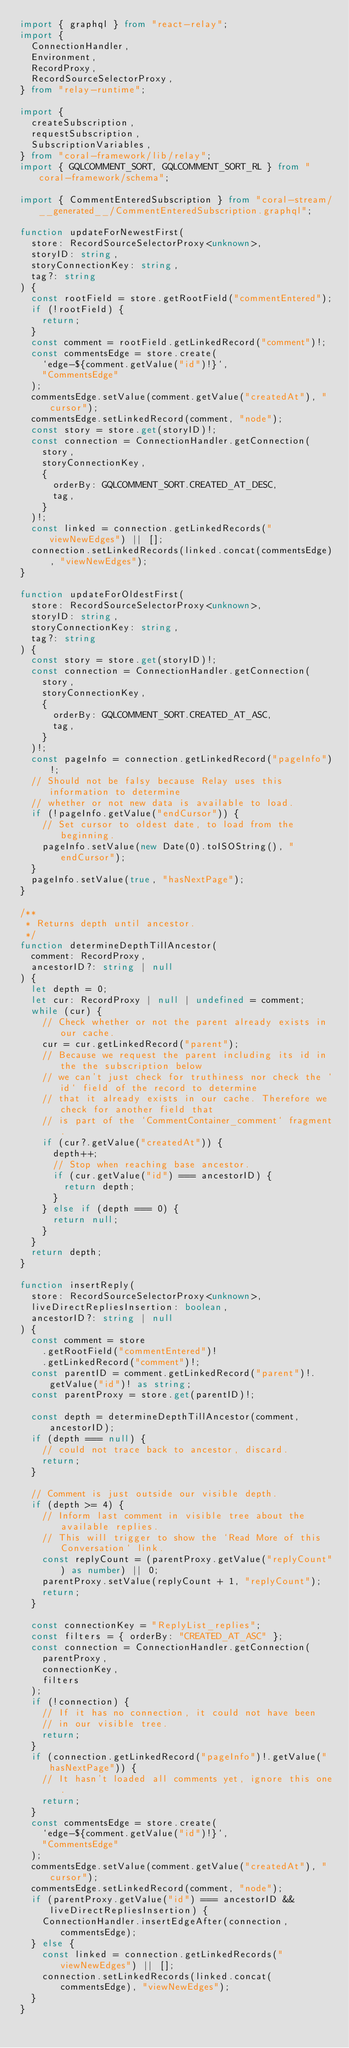Convert code to text. <code><loc_0><loc_0><loc_500><loc_500><_TypeScript_>import { graphql } from "react-relay";
import {
  ConnectionHandler,
  Environment,
  RecordProxy,
  RecordSourceSelectorProxy,
} from "relay-runtime";

import {
  createSubscription,
  requestSubscription,
  SubscriptionVariables,
} from "coral-framework/lib/relay";
import { GQLCOMMENT_SORT, GQLCOMMENT_SORT_RL } from "coral-framework/schema";

import { CommentEnteredSubscription } from "coral-stream/__generated__/CommentEnteredSubscription.graphql";

function updateForNewestFirst(
  store: RecordSourceSelectorProxy<unknown>,
  storyID: string,
  storyConnectionKey: string,
  tag?: string
) {
  const rootField = store.getRootField("commentEntered");
  if (!rootField) {
    return;
  }
  const comment = rootField.getLinkedRecord("comment")!;
  const commentsEdge = store.create(
    `edge-${comment.getValue("id")!}`,
    "CommentsEdge"
  );
  commentsEdge.setValue(comment.getValue("createdAt"), "cursor");
  commentsEdge.setLinkedRecord(comment, "node");
  const story = store.get(storyID)!;
  const connection = ConnectionHandler.getConnection(
    story,
    storyConnectionKey,
    {
      orderBy: GQLCOMMENT_SORT.CREATED_AT_DESC,
      tag,
    }
  )!;
  const linked = connection.getLinkedRecords("viewNewEdges") || [];
  connection.setLinkedRecords(linked.concat(commentsEdge), "viewNewEdges");
}

function updateForOldestFirst(
  store: RecordSourceSelectorProxy<unknown>,
  storyID: string,
  storyConnectionKey: string,
  tag?: string
) {
  const story = store.get(storyID)!;
  const connection = ConnectionHandler.getConnection(
    story,
    storyConnectionKey,
    {
      orderBy: GQLCOMMENT_SORT.CREATED_AT_ASC,
      tag,
    }
  )!;
  const pageInfo = connection.getLinkedRecord("pageInfo")!;
  // Should not be falsy because Relay uses this information to determine
  // whether or not new data is available to load.
  if (!pageInfo.getValue("endCursor")) {
    // Set cursor to oldest date, to load from the beginning.
    pageInfo.setValue(new Date(0).toISOString(), "endCursor");
  }
  pageInfo.setValue(true, "hasNextPage");
}

/**
 * Returns depth until ancestor.
 */
function determineDepthTillAncestor(
  comment: RecordProxy,
  ancestorID?: string | null
) {
  let depth = 0;
  let cur: RecordProxy | null | undefined = comment;
  while (cur) {
    // Check whether or not the parent already exists in our cache.
    cur = cur.getLinkedRecord("parent");
    // Because we request the parent including its id in the the subscription below
    // we can't just check for truthiness nor check the `id` field of the record to determine
    // that it already exists in our cache. Therefore we check for another field that
    // is part of the `CommentContainer_comment` fragment.
    if (cur?.getValue("createdAt")) {
      depth++;
      // Stop when reaching base ancestor.
      if (cur.getValue("id") === ancestorID) {
        return depth;
      }
    } else if (depth === 0) {
      return null;
    }
  }
  return depth;
}

function insertReply(
  store: RecordSourceSelectorProxy<unknown>,
  liveDirectRepliesInsertion: boolean,
  ancestorID?: string | null
) {
  const comment = store
    .getRootField("commentEntered")!
    .getLinkedRecord("comment")!;
  const parentID = comment.getLinkedRecord("parent")!.getValue("id")! as string;
  const parentProxy = store.get(parentID)!;

  const depth = determineDepthTillAncestor(comment, ancestorID);
  if (depth === null) {
    // could not trace back to ancestor, discard.
    return;
  }

  // Comment is just outside our visible depth.
  if (depth >= 4) {
    // Inform last comment in visible tree about the available replies.
    // This will trigger to show the `Read More of this Conversation` link.
    const replyCount = (parentProxy.getValue("replyCount") as number) || 0;
    parentProxy.setValue(replyCount + 1, "replyCount");
    return;
  }

  const connectionKey = "ReplyList_replies";
  const filters = { orderBy: "CREATED_AT_ASC" };
  const connection = ConnectionHandler.getConnection(
    parentProxy,
    connectionKey,
    filters
  );
  if (!connection) {
    // If it has no connection, it could not have been
    // in our visible tree.
    return;
  }
  if (connection.getLinkedRecord("pageInfo")!.getValue("hasNextPage")) {
    // It hasn't loaded all comments yet, ignore this one.
    return;
  }
  const commentsEdge = store.create(
    `edge-${comment.getValue("id")!}`,
    "CommentsEdge"
  );
  commentsEdge.setValue(comment.getValue("createdAt"), "cursor");
  commentsEdge.setLinkedRecord(comment, "node");
  if (parentProxy.getValue("id") === ancestorID && liveDirectRepliesInsertion) {
    ConnectionHandler.insertEdgeAfter(connection, commentsEdge);
  } else {
    const linked = connection.getLinkedRecords("viewNewEdges") || [];
    connection.setLinkedRecords(linked.concat(commentsEdge), "viewNewEdges");
  }
}
</code> 